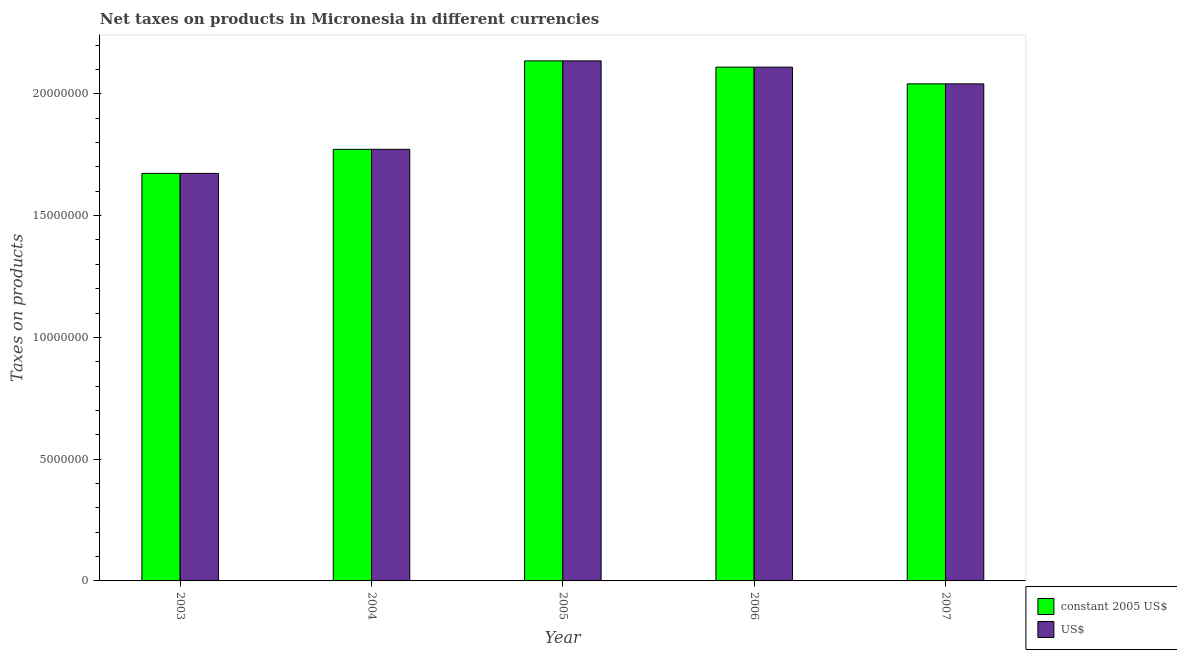How many different coloured bars are there?
Offer a terse response. 2. How many groups of bars are there?
Offer a very short reply. 5. How many bars are there on the 5th tick from the right?
Keep it short and to the point. 2. What is the label of the 3rd group of bars from the left?
Your answer should be very brief. 2005. What is the net taxes in us$ in 2007?
Provide a succinct answer. 2.04e+07. Across all years, what is the maximum net taxes in constant 2005 us$?
Provide a succinct answer. 2.14e+07. Across all years, what is the minimum net taxes in us$?
Your response must be concise. 1.67e+07. In which year was the net taxes in constant 2005 us$ maximum?
Your answer should be compact. 2005. What is the total net taxes in constant 2005 us$ in the graph?
Your response must be concise. 9.73e+07. What is the difference between the net taxes in us$ in 2005 and that in 2007?
Offer a very short reply. 9.44e+05. What is the difference between the net taxes in us$ in 2005 and the net taxes in constant 2005 us$ in 2006?
Keep it short and to the point. 2.57e+05. What is the average net taxes in constant 2005 us$ per year?
Your answer should be compact. 1.95e+07. What is the ratio of the net taxes in constant 2005 us$ in 2004 to that in 2006?
Provide a succinct answer. 0.84. Is the net taxes in constant 2005 us$ in 2006 less than that in 2007?
Your answer should be very brief. No. What is the difference between the highest and the second highest net taxes in us$?
Give a very brief answer. 2.57e+05. What is the difference between the highest and the lowest net taxes in us$?
Offer a very short reply. 4.62e+06. What does the 2nd bar from the left in 2006 represents?
Your answer should be very brief. US$. What does the 1st bar from the right in 2003 represents?
Provide a succinct answer. US$. How many bars are there?
Ensure brevity in your answer.  10. Are all the bars in the graph horizontal?
Make the answer very short. No. Does the graph contain any zero values?
Give a very brief answer. No. Where does the legend appear in the graph?
Your answer should be very brief. Bottom right. How many legend labels are there?
Your answer should be compact. 2. How are the legend labels stacked?
Provide a succinct answer. Vertical. What is the title of the graph?
Your response must be concise. Net taxes on products in Micronesia in different currencies. Does "Secondary" appear as one of the legend labels in the graph?
Your answer should be compact. No. What is the label or title of the Y-axis?
Your response must be concise. Taxes on products. What is the Taxes on products of constant 2005 US$ in 2003?
Offer a terse response. 1.67e+07. What is the Taxes on products of US$ in 2003?
Your response must be concise. 1.67e+07. What is the Taxes on products in constant 2005 US$ in 2004?
Provide a short and direct response. 1.77e+07. What is the Taxes on products of US$ in 2004?
Give a very brief answer. 1.77e+07. What is the Taxes on products of constant 2005 US$ in 2005?
Provide a short and direct response. 2.14e+07. What is the Taxes on products in US$ in 2005?
Offer a terse response. 2.14e+07. What is the Taxes on products in constant 2005 US$ in 2006?
Give a very brief answer. 2.11e+07. What is the Taxes on products in US$ in 2006?
Your response must be concise. 2.11e+07. What is the Taxes on products in constant 2005 US$ in 2007?
Your answer should be compact. 2.04e+07. What is the Taxes on products in US$ in 2007?
Ensure brevity in your answer.  2.04e+07. Across all years, what is the maximum Taxes on products in constant 2005 US$?
Offer a very short reply. 2.14e+07. Across all years, what is the maximum Taxes on products of US$?
Make the answer very short. 2.14e+07. Across all years, what is the minimum Taxes on products in constant 2005 US$?
Provide a succinct answer. 1.67e+07. Across all years, what is the minimum Taxes on products in US$?
Offer a very short reply. 1.67e+07. What is the total Taxes on products of constant 2005 US$ in the graph?
Provide a succinct answer. 9.73e+07. What is the total Taxes on products in US$ in the graph?
Your response must be concise. 9.73e+07. What is the difference between the Taxes on products of constant 2005 US$ in 2003 and that in 2004?
Make the answer very short. -9.89e+05. What is the difference between the Taxes on products in US$ in 2003 and that in 2004?
Your answer should be compact. -9.89e+05. What is the difference between the Taxes on products of constant 2005 US$ in 2003 and that in 2005?
Provide a short and direct response. -4.62e+06. What is the difference between the Taxes on products of US$ in 2003 and that in 2005?
Offer a terse response. -4.62e+06. What is the difference between the Taxes on products in constant 2005 US$ in 2003 and that in 2006?
Offer a terse response. -4.36e+06. What is the difference between the Taxes on products of US$ in 2003 and that in 2006?
Ensure brevity in your answer.  -4.36e+06. What is the difference between the Taxes on products of constant 2005 US$ in 2003 and that in 2007?
Make the answer very short. -3.68e+06. What is the difference between the Taxes on products of US$ in 2003 and that in 2007?
Provide a short and direct response. -3.68e+06. What is the difference between the Taxes on products of constant 2005 US$ in 2004 and that in 2005?
Your response must be concise. -3.63e+06. What is the difference between the Taxes on products in US$ in 2004 and that in 2005?
Give a very brief answer. -3.63e+06. What is the difference between the Taxes on products of constant 2005 US$ in 2004 and that in 2006?
Your answer should be compact. -3.38e+06. What is the difference between the Taxes on products in US$ in 2004 and that in 2006?
Your response must be concise. -3.38e+06. What is the difference between the Taxes on products in constant 2005 US$ in 2004 and that in 2007?
Ensure brevity in your answer.  -2.69e+06. What is the difference between the Taxes on products of US$ in 2004 and that in 2007?
Ensure brevity in your answer.  -2.69e+06. What is the difference between the Taxes on products in constant 2005 US$ in 2005 and that in 2006?
Give a very brief answer. 2.57e+05. What is the difference between the Taxes on products in US$ in 2005 and that in 2006?
Offer a very short reply. 2.57e+05. What is the difference between the Taxes on products of constant 2005 US$ in 2005 and that in 2007?
Your response must be concise. 9.44e+05. What is the difference between the Taxes on products of US$ in 2005 and that in 2007?
Give a very brief answer. 9.44e+05. What is the difference between the Taxes on products of constant 2005 US$ in 2006 and that in 2007?
Make the answer very short. 6.88e+05. What is the difference between the Taxes on products in US$ in 2006 and that in 2007?
Ensure brevity in your answer.  6.88e+05. What is the difference between the Taxes on products of constant 2005 US$ in 2003 and the Taxes on products of US$ in 2004?
Provide a succinct answer. -9.89e+05. What is the difference between the Taxes on products of constant 2005 US$ in 2003 and the Taxes on products of US$ in 2005?
Make the answer very short. -4.62e+06. What is the difference between the Taxes on products in constant 2005 US$ in 2003 and the Taxes on products in US$ in 2006?
Give a very brief answer. -4.36e+06. What is the difference between the Taxes on products in constant 2005 US$ in 2003 and the Taxes on products in US$ in 2007?
Provide a short and direct response. -3.68e+06. What is the difference between the Taxes on products in constant 2005 US$ in 2004 and the Taxes on products in US$ in 2005?
Provide a short and direct response. -3.63e+06. What is the difference between the Taxes on products of constant 2005 US$ in 2004 and the Taxes on products of US$ in 2006?
Your response must be concise. -3.38e+06. What is the difference between the Taxes on products in constant 2005 US$ in 2004 and the Taxes on products in US$ in 2007?
Ensure brevity in your answer.  -2.69e+06. What is the difference between the Taxes on products of constant 2005 US$ in 2005 and the Taxes on products of US$ in 2006?
Give a very brief answer. 2.57e+05. What is the difference between the Taxes on products in constant 2005 US$ in 2005 and the Taxes on products in US$ in 2007?
Offer a very short reply. 9.44e+05. What is the difference between the Taxes on products of constant 2005 US$ in 2006 and the Taxes on products of US$ in 2007?
Offer a very short reply. 6.88e+05. What is the average Taxes on products of constant 2005 US$ per year?
Provide a short and direct response. 1.95e+07. What is the average Taxes on products of US$ per year?
Ensure brevity in your answer.  1.95e+07. In the year 2003, what is the difference between the Taxes on products of constant 2005 US$ and Taxes on products of US$?
Offer a very short reply. 0. In the year 2004, what is the difference between the Taxes on products of constant 2005 US$ and Taxes on products of US$?
Provide a short and direct response. 0. In the year 2005, what is the difference between the Taxes on products of constant 2005 US$ and Taxes on products of US$?
Provide a short and direct response. 0. In the year 2006, what is the difference between the Taxes on products of constant 2005 US$ and Taxes on products of US$?
Ensure brevity in your answer.  0. In the year 2007, what is the difference between the Taxes on products of constant 2005 US$ and Taxes on products of US$?
Your response must be concise. 0. What is the ratio of the Taxes on products of constant 2005 US$ in 2003 to that in 2004?
Your answer should be compact. 0.94. What is the ratio of the Taxes on products in US$ in 2003 to that in 2004?
Provide a succinct answer. 0.94. What is the ratio of the Taxes on products of constant 2005 US$ in 2003 to that in 2005?
Keep it short and to the point. 0.78. What is the ratio of the Taxes on products in US$ in 2003 to that in 2005?
Your answer should be compact. 0.78. What is the ratio of the Taxes on products in constant 2005 US$ in 2003 to that in 2006?
Ensure brevity in your answer.  0.79. What is the ratio of the Taxes on products of US$ in 2003 to that in 2006?
Provide a succinct answer. 0.79. What is the ratio of the Taxes on products of constant 2005 US$ in 2003 to that in 2007?
Give a very brief answer. 0.82. What is the ratio of the Taxes on products in US$ in 2003 to that in 2007?
Ensure brevity in your answer.  0.82. What is the ratio of the Taxes on products of constant 2005 US$ in 2004 to that in 2005?
Ensure brevity in your answer.  0.83. What is the ratio of the Taxes on products in US$ in 2004 to that in 2005?
Your answer should be compact. 0.83. What is the ratio of the Taxes on products in constant 2005 US$ in 2004 to that in 2006?
Offer a terse response. 0.84. What is the ratio of the Taxes on products in US$ in 2004 to that in 2006?
Keep it short and to the point. 0.84. What is the ratio of the Taxes on products in constant 2005 US$ in 2004 to that in 2007?
Your answer should be very brief. 0.87. What is the ratio of the Taxes on products in US$ in 2004 to that in 2007?
Offer a terse response. 0.87. What is the ratio of the Taxes on products in constant 2005 US$ in 2005 to that in 2006?
Offer a terse response. 1.01. What is the ratio of the Taxes on products in US$ in 2005 to that in 2006?
Offer a very short reply. 1.01. What is the ratio of the Taxes on products in constant 2005 US$ in 2005 to that in 2007?
Your answer should be very brief. 1.05. What is the ratio of the Taxes on products in US$ in 2005 to that in 2007?
Offer a terse response. 1.05. What is the ratio of the Taxes on products of constant 2005 US$ in 2006 to that in 2007?
Give a very brief answer. 1.03. What is the ratio of the Taxes on products in US$ in 2006 to that in 2007?
Give a very brief answer. 1.03. What is the difference between the highest and the second highest Taxes on products of constant 2005 US$?
Offer a very short reply. 2.57e+05. What is the difference between the highest and the second highest Taxes on products of US$?
Offer a very short reply. 2.57e+05. What is the difference between the highest and the lowest Taxes on products in constant 2005 US$?
Your answer should be compact. 4.62e+06. What is the difference between the highest and the lowest Taxes on products in US$?
Offer a terse response. 4.62e+06. 